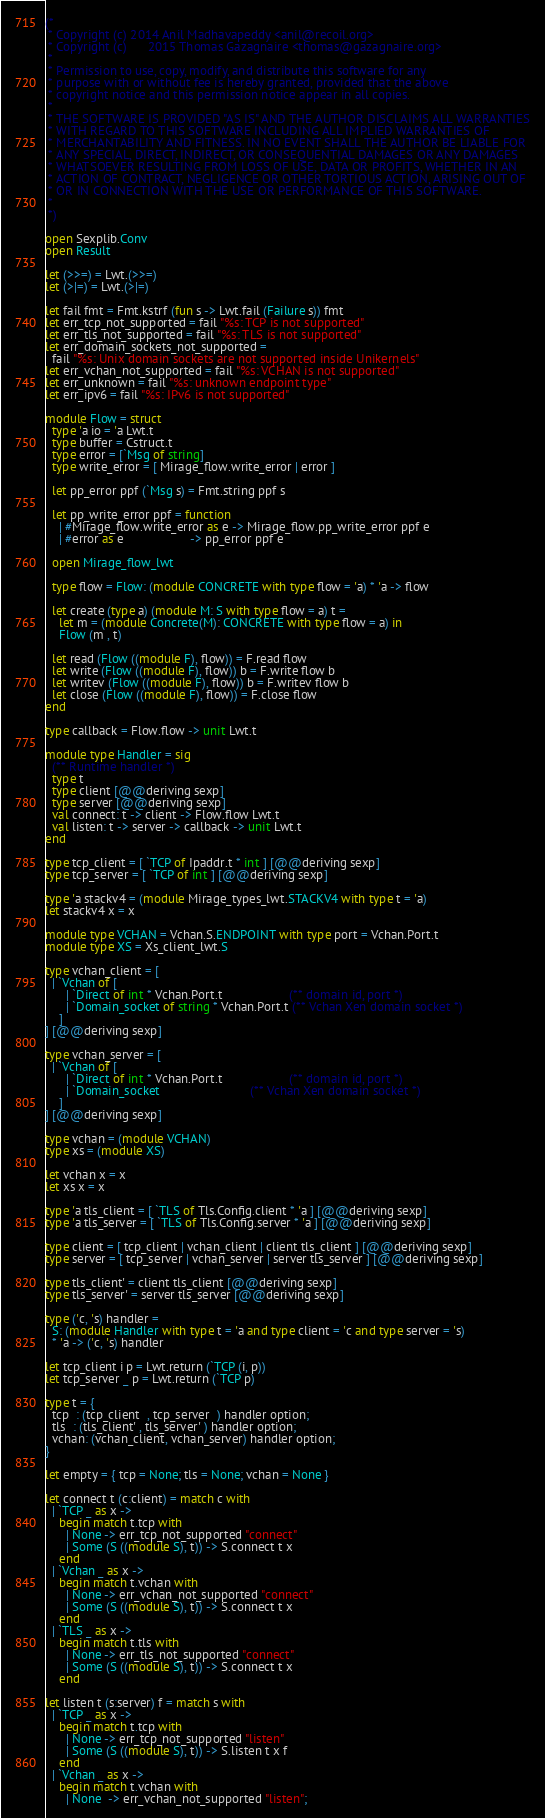Convert code to text. <code><loc_0><loc_0><loc_500><loc_500><_OCaml_>(*
 * Copyright (c) 2014 Anil Madhavapeddy <anil@recoil.org>
 * Copyright (c)      2015 Thomas Gazagnaire <thomas@gazagnaire.org>
 *
 * Permission to use, copy, modify, and distribute this software for any
 * purpose with or without fee is hereby granted, provided that the above
 * copyright notice and this permission notice appear in all copies.
 *
 * THE SOFTWARE IS PROVIDED "AS IS" AND THE AUTHOR DISCLAIMS ALL WARRANTIES
 * WITH REGARD TO THIS SOFTWARE INCLUDING ALL IMPLIED WARRANTIES OF
 * MERCHANTABILITY AND FITNESS. IN NO EVENT SHALL THE AUTHOR BE LIABLE FOR
 * ANY SPECIAL, DIRECT, INDIRECT, OR CONSEQUENTIAL DAMAGES OR ANY DAMAGES
 * WHATSOEVER RESULTING FROM LOSS OF USE, DATA OR PROFITS, WHETHER IN AN
 * ACTION OF CONTRACT, NEGLIGENCE OR OTHER TORTIOUS ACTION, ARISING OUT OF
 * OR IN CONNECTION WITH THE USE OR PERFORMANCE OF THIS SOFTWARE.
 *
 *)

open Sexplib.Conv
open Result

let (>>=) = Lwt.(>>=)
let (>|=) = Lwt.(>|=)

let fail fmt = Fmt.kstrf (fun s -> Lwt.fail (Failure s)) fmt
let err_tcp_not_supported = fail "%s: TCP is not supported"
let err_tls_not_supported = fail "%s: TLS is not supported"
let err_domain_sockets_not_supported =
  fail "%s: Unix domain sockets are not supported inside Unikernels"
let err_vchan_not_supported = fail "%s: VCHAN is not supported"
let err_unknown = fail "%s: unknown endpoint type"
let err_ipv6 = fail "%s: IPv6 is not supported"

module Flow = struct
  type 'a io = 'a Lwt.t
  type buffer = Cstruct.t
  type error = [`Msg of string]
  type write_error = [ Mirage_flow.write_error | error ]

  let pp_error ppf (`Msg s) = Fmt.string ppf s

  let pp_write_error ppf = function
    | #Mirage_flow.write_error as e -> Mirage_flow.pp_write_error ppf e
    | #error as e                   -> pp_error ppf e

  open Mirage_flow_lwt

  type flow = Flow: (module CONCRETE with type flow = 'a) * 'a -> flow

  let create (type a) (module M: S with type flow = a) t =
    let m = (module Concrete(M): CONCRETE with type flow = a) in
    Flow (m , t)

  let read (Flow ((module F), flow)) = F.read flow
  let write (Flow ((module F), flow)) b = F.write flow b
  let writev (Flow ((module F), flow)) b = F.writev flow b
  let close (Flow ((module F), flow)) = F.close flow
end

type callback = Flow.flow -> unit Lwt.t

module type Handler = sig
  (** Runtime handler *)
  type t
  type client [@@deriving sexp]
  type server [@@deriving sexp]
  val connect: t -> client -> Flow.flow Lwt.t
  val listen: t -> server -> callback -> unit Lwt.t
end

type tcp_client = [ `TCP of Ipaddr.t * int ] [@@deriving sexp]
type tcp_server = [ `TCP of int ] [@@deriving sexp]

type 'a stackv4 = (module Mirage_types_lwt.STACKV4 with type t = 'a)
let stackv4 x = x

module type VCHAN = Vchan.S.ENDPOINT with type port = Vchan.Port.t
module type XS = Xs_client_lwt.S

type vchan_client = [
  | `Vchan of [
      | `Direct of int * Vchan.Port.t                   (** domain id, port *)
      | `Domain_socket of string * Vchan.Port.t (** Vchan Xen domain socket *)
    ]
] [@@deriving sexp]

type vchan_server = [
  | `Vchan of [
      | `Direct of int * Vchan.Port.t                   (** domain id, port *)
      | `Domain_socket                          (** Vchan Xen domain socket *)
    ]
] [@@deriving sexp]

type vchan = (module VCHAN)
type xs = (module XS)

let vchan x = x
let xs x = x

type 'a tls_client = [ `TLS of Tls.Config.client * 'a ] [@@deriving sexp]
type 'a tls_server = [ `TLS of Tls.Config.server * 'a ] [@@deriving sexp]

type client = [ tcp_client | vchan_client | client tls_client ] [@@deriving sexp]
type server = [ tcp_server | vchan_server | server tls_server ] [@@deriving sexp]

type tls_client' = client tls_client [@@deriving sexp]
type tls_server' = server tls_server [@@deriving sexp]

type ('c, 's) handler =
  S: (module Handler with type t = 'a and type client = 'c and type server = 's)
  * 'a -> ('c, 's) handler

let tcp_client i p = Lwt.return (`TCP (i, p))
let tcp_server _ p = Lwt.return (`TCP p)

type t = {
  tcp  : (tcp_client  , tcp_server  ) handler option;
  tls  : (tls_client' , tls_server' ) handler option;
  vchan: (vchan_client, vchan_server) handler option;
}

let empty = { tcp = None; tls = None; vchan = None }

let connect t (c:client) = match c with
  | `TCP _ as x ->
    begin match t.tcp with
      | None -> err_tcp_not_supported "connect"
      | Some (S ((module S), t)) -> S.connect t x
    end
  | `Vchan _ as x ->
    begin match t.vchan with
      | None -> err_vchan_not_supported "connect"
      | Some (S ((module S), t)) -> S.connect t x
    end
  | `TLS _ as x ->
    begin match t.tls with
      | None -> err_tls_not_supported "connect"
      | Some (S ((module S), t)) -> S.connect t x
    end

let listen t (s:server) f = match s with
  | `TCP _ as x ->
    begin match t.tcp with
      | None -> err_tcp_not_supported "listen"
      | Some (S ((module S), t)) -> S.listen t x f
    end
  | `Vchan _ as x ->
    begin match t.vchan with
      | None  -> err_vchan_not_supported "listen";</code> 